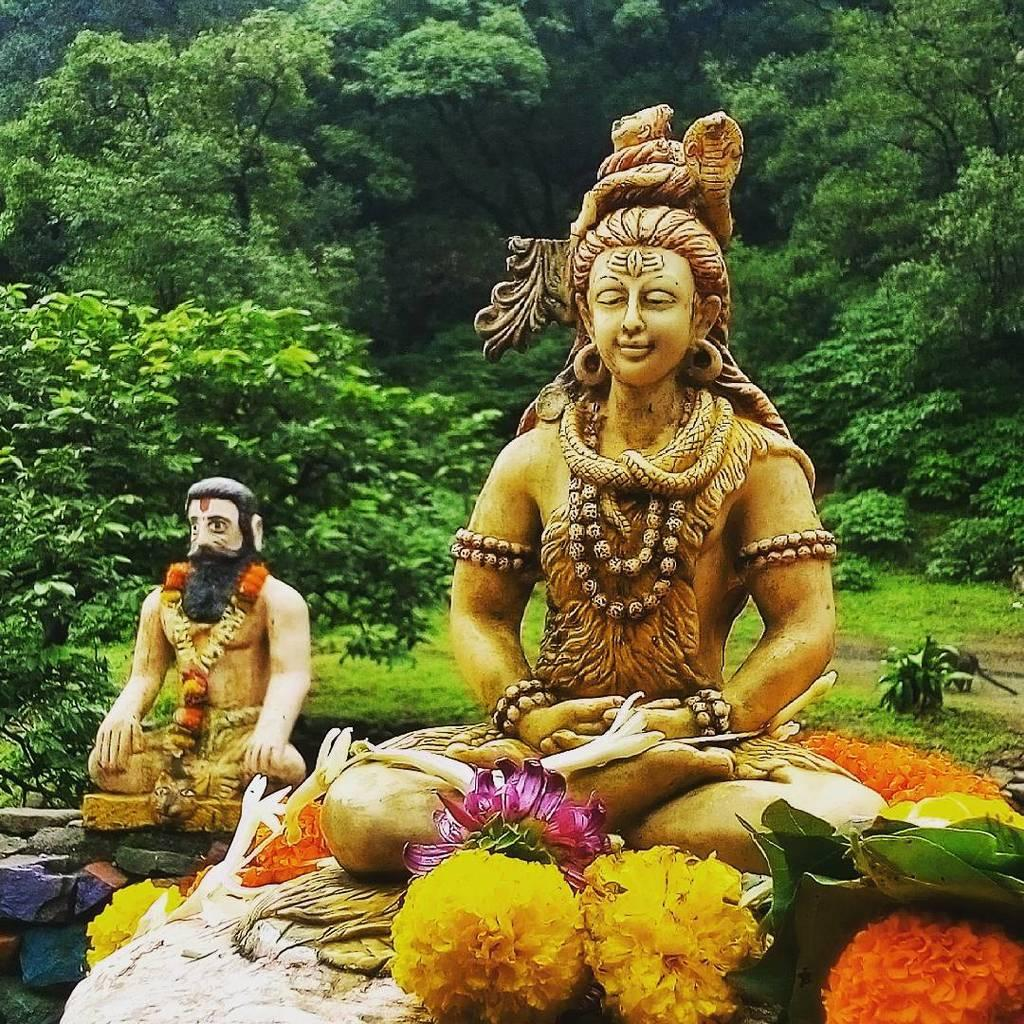What can be found at the bottom of the image? There are two sculptures and flowers in the bottom of the image. Can you describe the sculptures in the image? Unfortunately, the facts provided do not give enough detail to describe the sculptures. What is visible in the background of the image? There are trees in the background of the image. What is the title of the room where the sculptures are displayed? The facts provided do not mention a room or a title, so we cannot answer this question. 